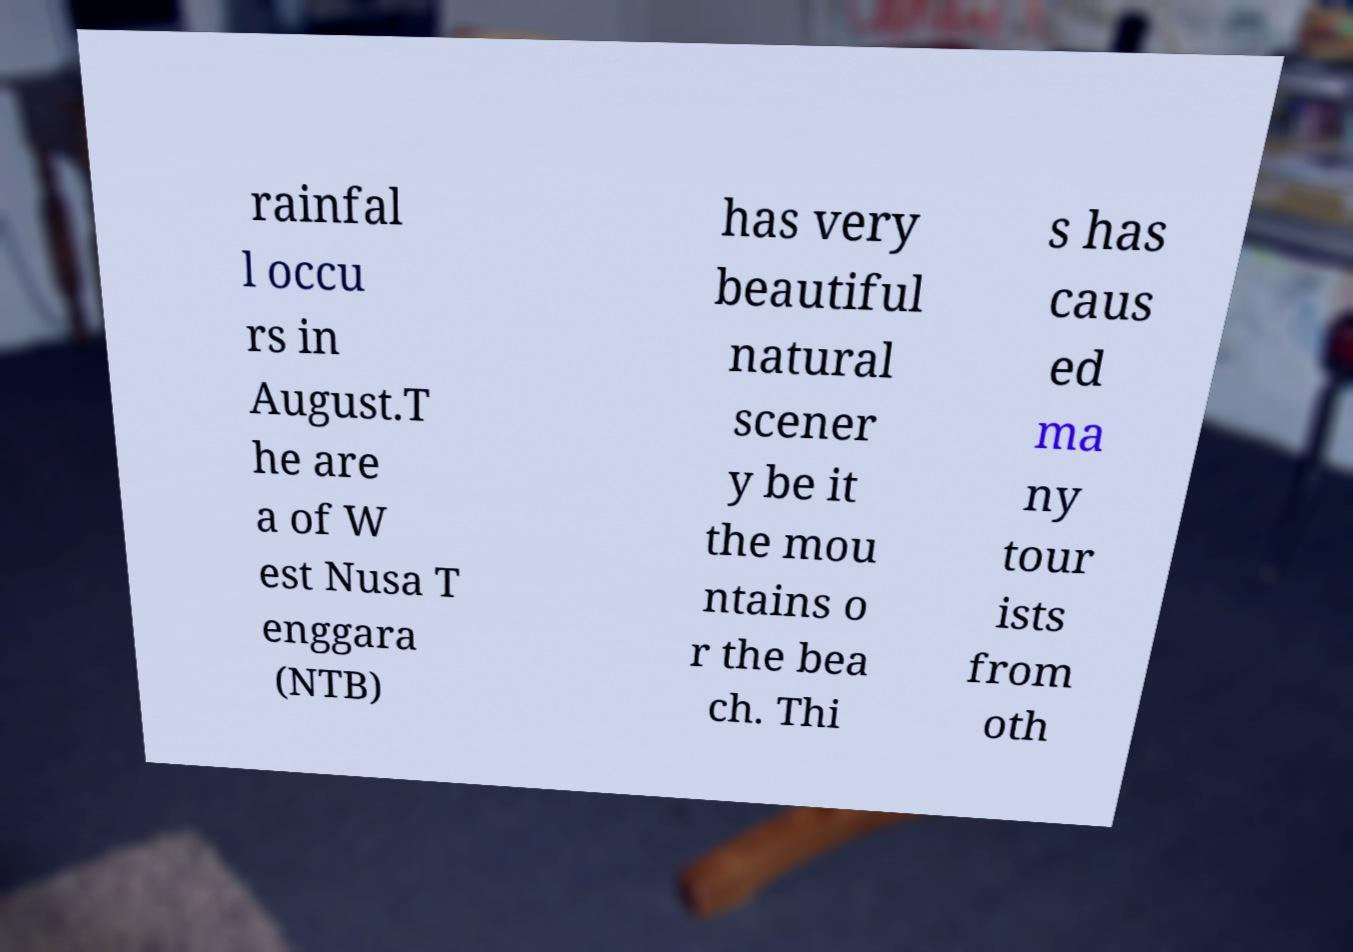I need the written content from this picture converted into text. Can you do that? rainfal l occu rs in August.T he are a of W est Nusa T enggara (NTB) has very beautiful natural scener y be it the mou ntains o r the bea ch. Thi s has caus ed ma ny tour ists from oth 